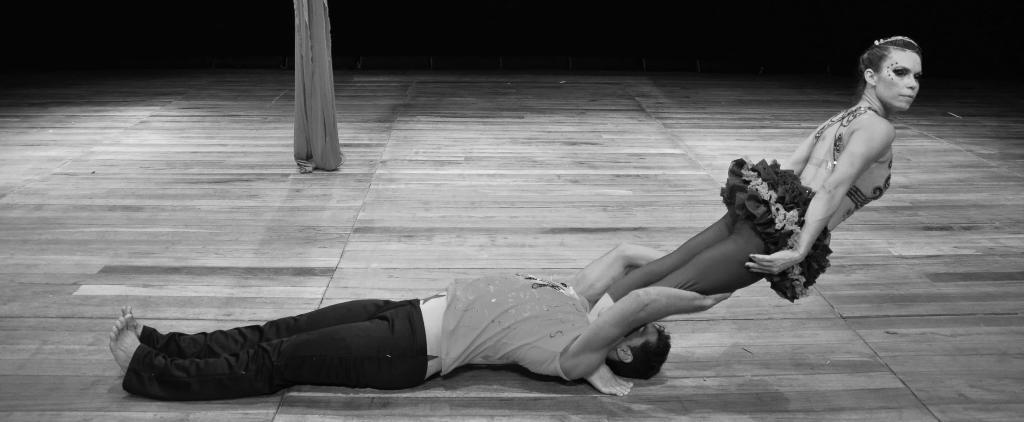What is the main subject of the image? There is a man in the image. What is the man doing in the image? The man is lying on the floor. Is there anyone else in the image besides the man? Yes, the man is holding a woman in his hands. What type of alarm is going off in the image? There is no alarm present in the image. Can you describe the sidewalk in the image? There is no sidewalk present in the image. 